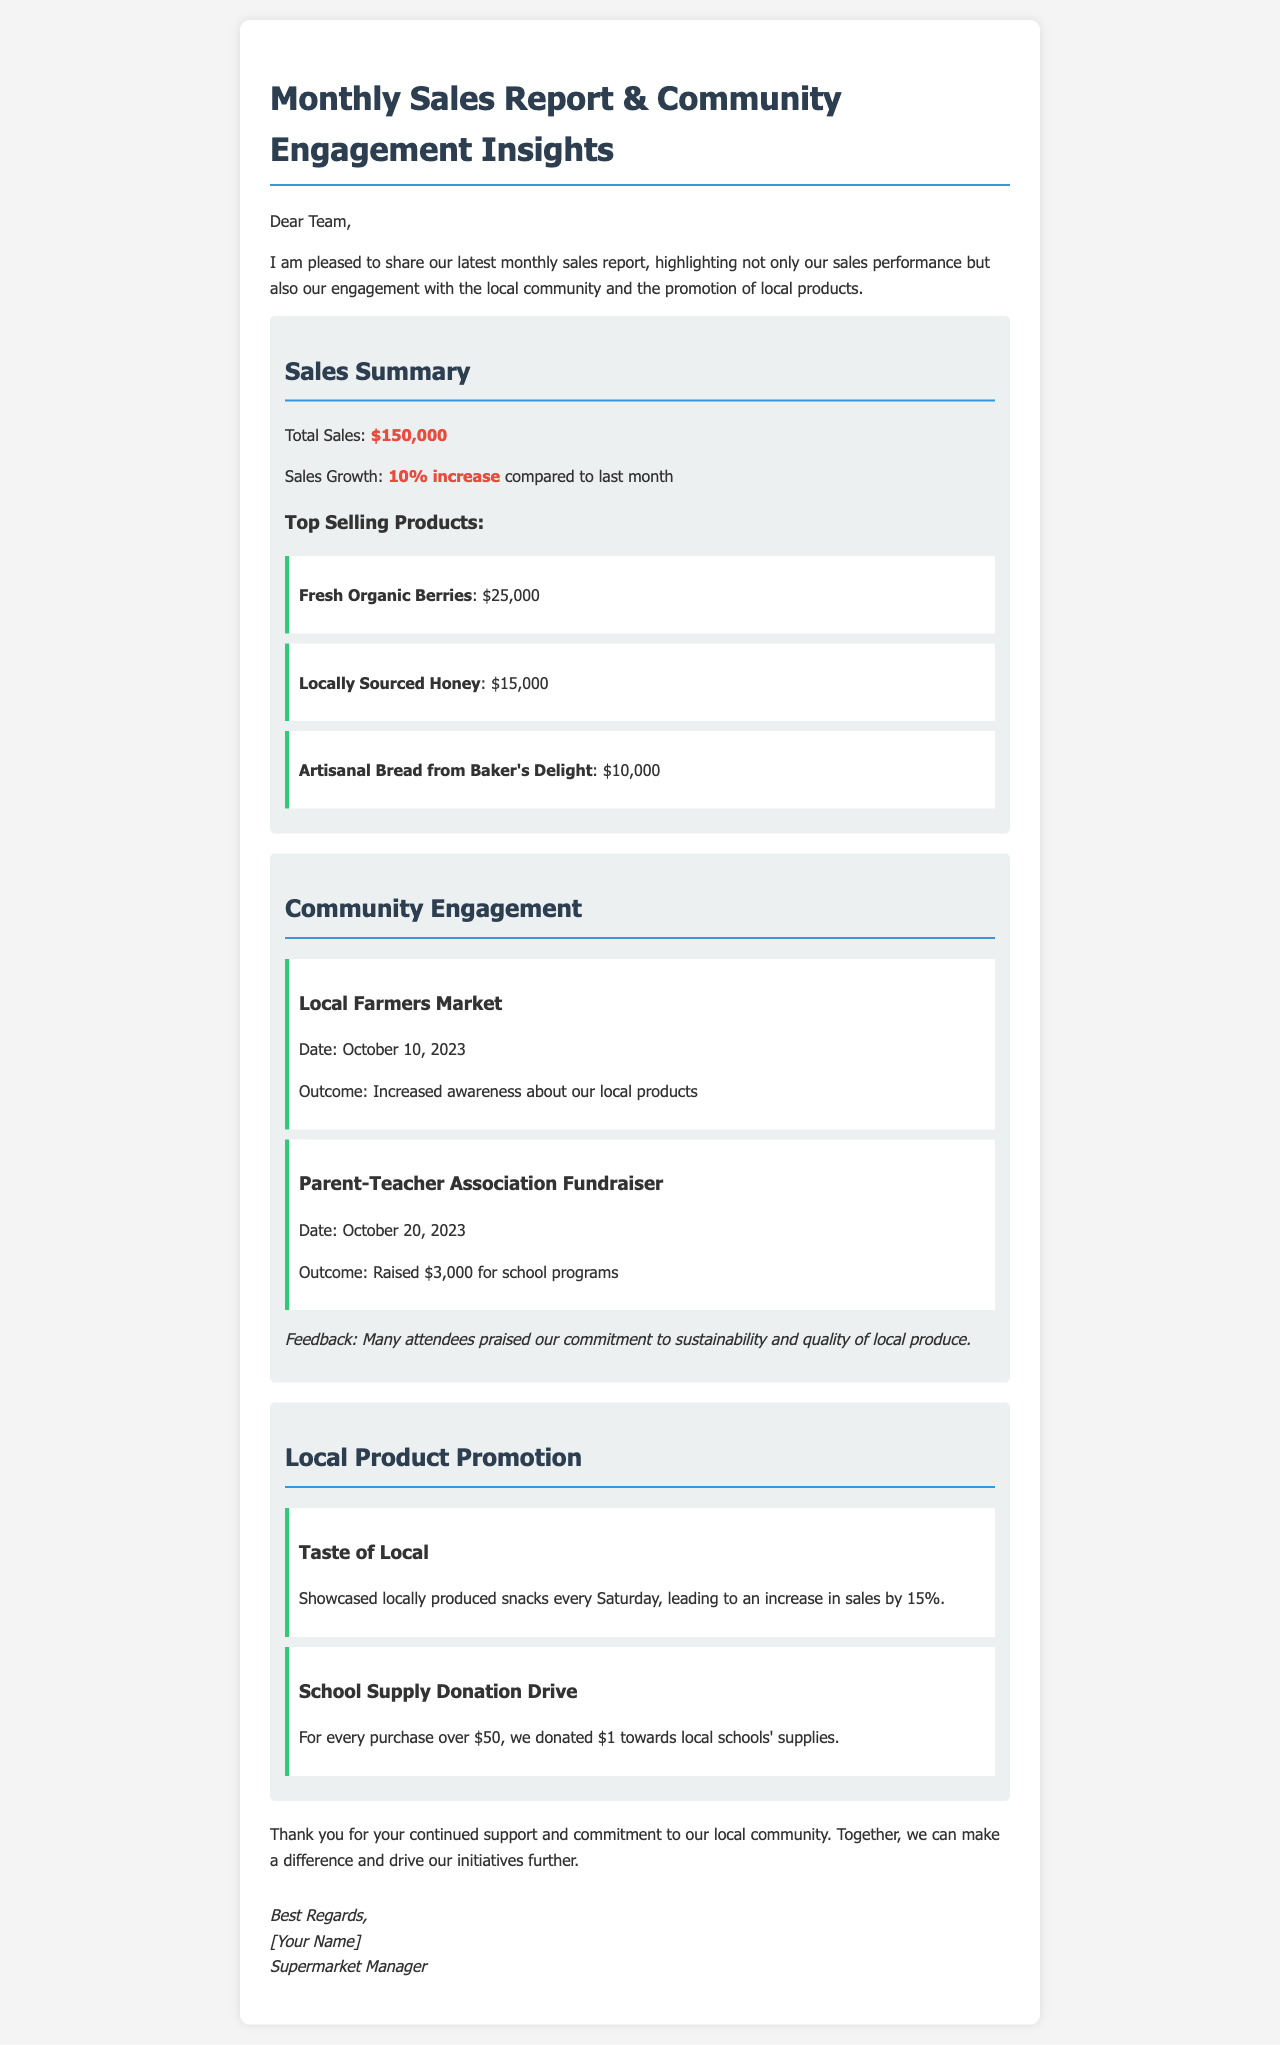What is the total sales for the month? The total sales figure is provided in the sales summary section of the document, which is $150,000.
Answer: $150,000 How much did sales grow compared to last month? The document indicates the percentage increase in sales growth in the sales summary section as a 10% increase.
Answer: 10% increase What are the top selling products listed? The sales summary section lists the top selling products along with their sales amounts, specifying "Fresh Organic Berries," "Locally Sourced Honey," and "Artisanal Bread from Baker's Delight."
Answer: Fresh Organic Berries, Locally Sourced Honey, Artisanal Bread from Baker's Delight What was the outcome of the Local Farmers Market event? The outcome of this event, as stated in the community engagement section, was to "Increase awareness about our local products."
Answer: Increased awareness about our local products How much money was raised during the Parent-Teacher Association Fundraiser? The document specifically states that $3,000 was raised for school programs during this fundraiser event.
Answer: $3,000 By what percentage did the "Taste of Local" initiative increase sales? The document mentions a 15% increase in sales due to this initiative.
Answer: 15% What does the School Supply Donation Drive contribute to? This initiative contributes $1 towards local schools' supplies for every purchase over $50.
Answer: $1 towards local schools' supplies What feedback was received from attendees at community events? Attendee feedback highlighted the supermarket's "commitment to sustainability and quality of local produce."
Answer: Commitment to sustainability and quality of local produce What is the date of the Local Farmers Market event? The date for this specific event is provided in the community engagement section of the document as October 10, 2023.
Answer: October 10, 2023 